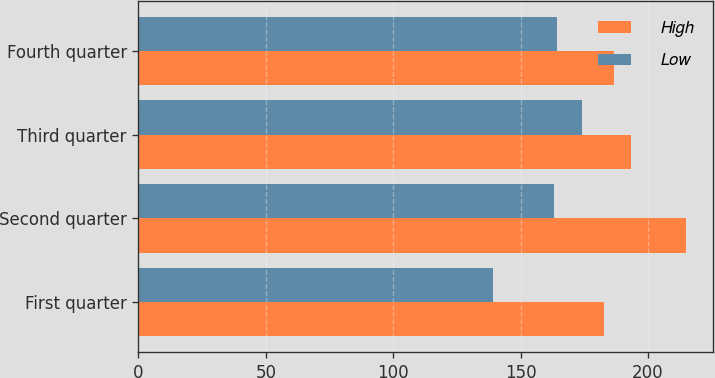Convert chart to OTSL. <chart><loc_0><loc_0><loc_500><loc_500><stacked_bar_chart><ecel><fcel>First quarter<fcel>Second quarter<fcel>Third quarter<fcel>Fourth quarter<nl><fcel>High<fcel>182.79<fcel>214.92<fcel>193.14<fcel>186.67<nl><fcel>Low<fcel>139.09<fcel>163.07<fcel>174.16<fcel>164.25<nl></chart> 